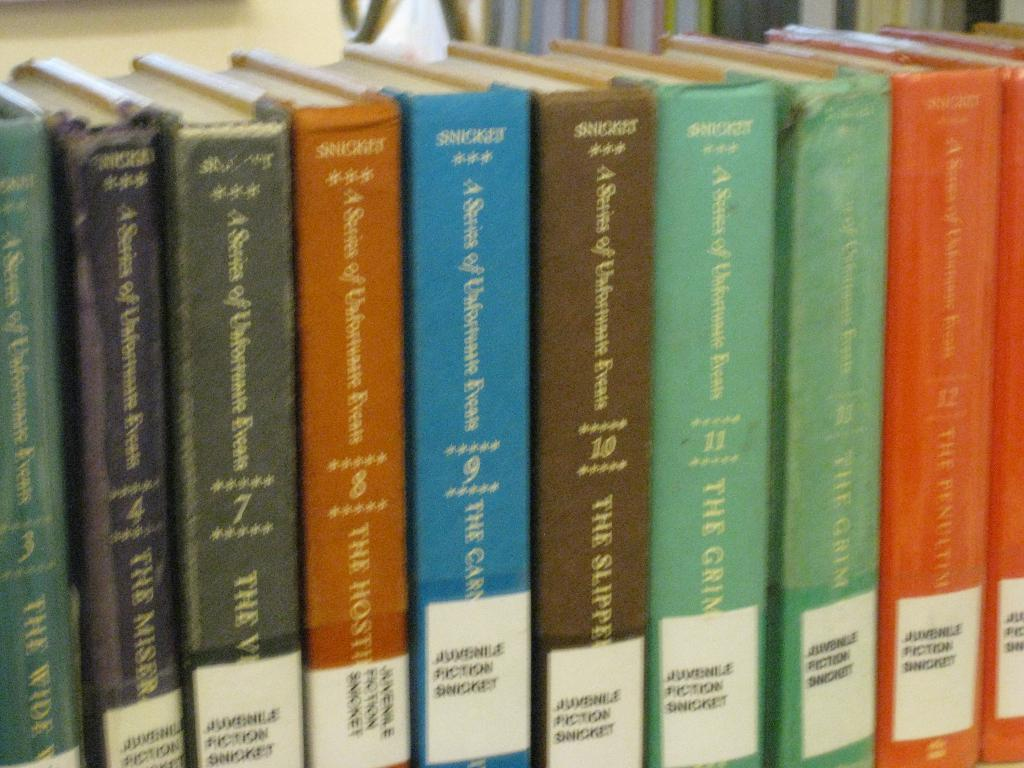<image>
Present a compact description of the photo's key features. a blue book among others that says snicket on it 